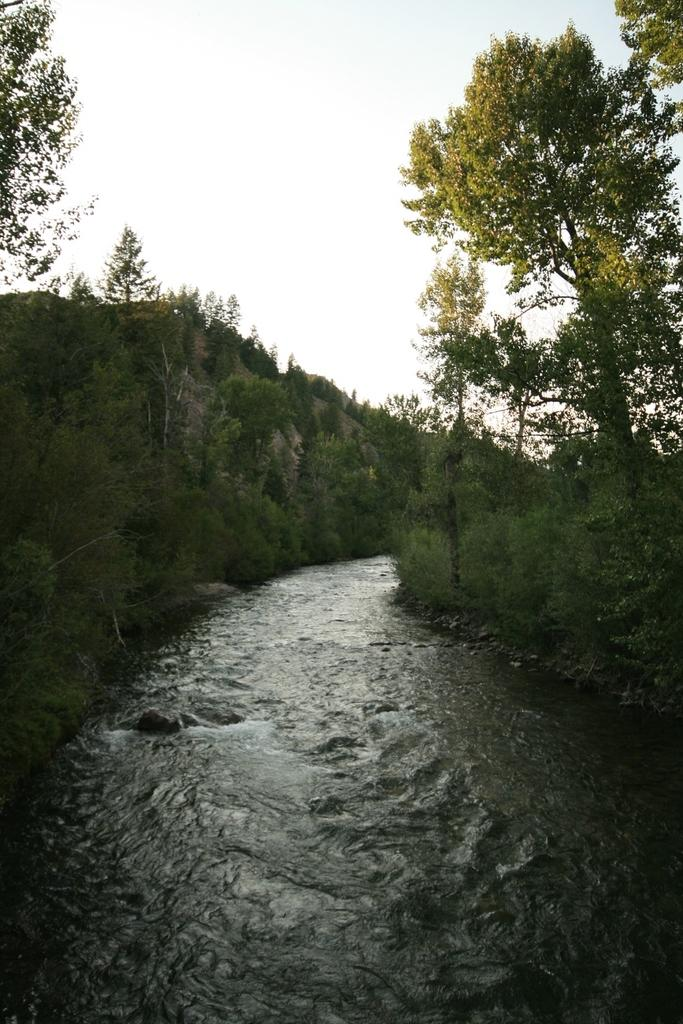What can be seen in the background of the image? The sky is visible in the background of the image. What is located on either side of the water in the image? There are trees and plants on either side of the water in the image. How many gold coins can be seen floating in the water in the image? There are no gold coins present in the image; it features trees, plants, and water. What type of bird can be seen flying through the rainstorm in the image? There is no rainstorm or bird present in the image; it features the sky, trees, plants, and water. 